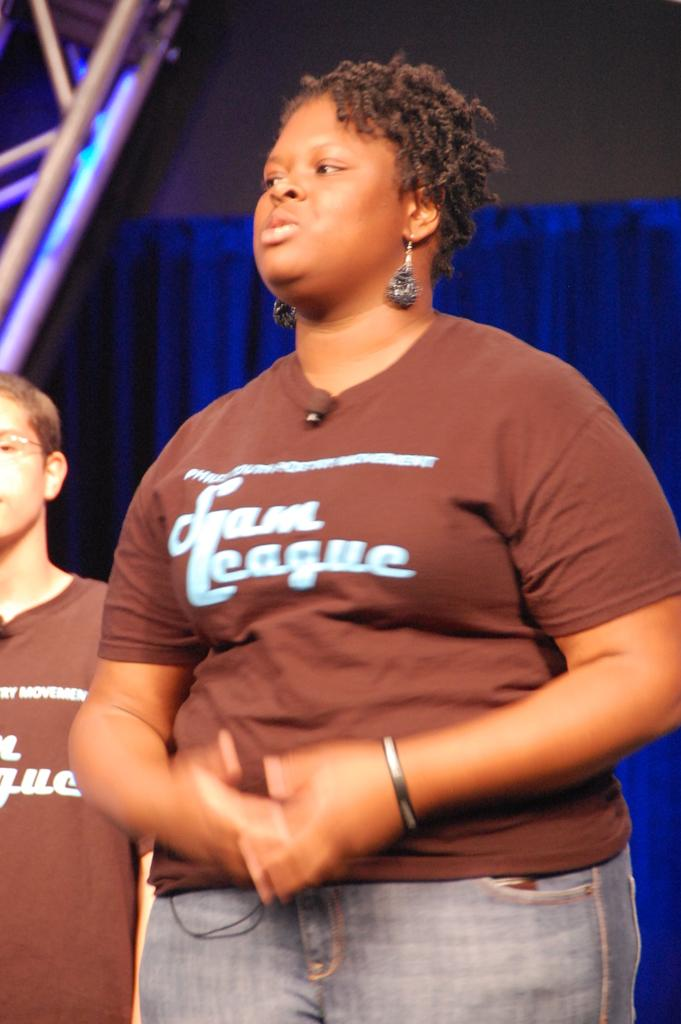Provide a one-sentence caption for the provided image. A woman in a brown shirt that says Team League. 